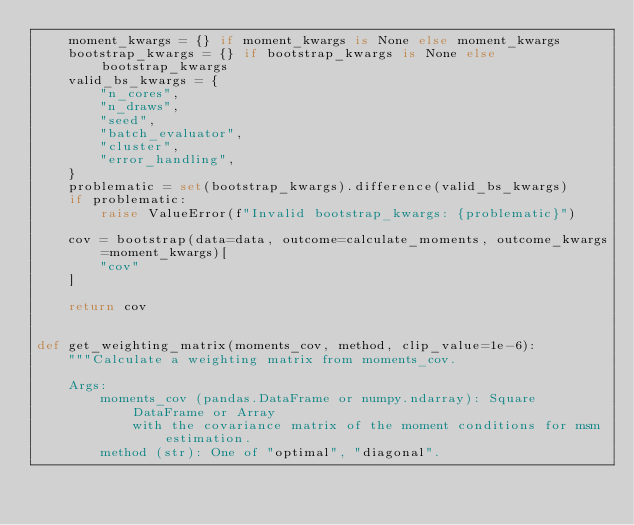Convert code to text. <code><loc_0><loc_0><loc_500><loc_500><_Python_>    moment_kwargs = {} if moment_kwargs is None else moment_kwargs
    bootstrap_kwargs = {} if bootstrap_kwargs is None else bootstrap_kwargs
    valid_bs_kwargs = {
        "n_cores",
        "n_draws",
        "seed",
        "batch_evaluator",
        "cluster",
        "error_handling",
    }
    problematic = set(bootstrap_kwargs).difference(valid_bs_kwargs)
    if problematic:
        raise ValueError(f"Invalid bootstrap_kwargs: {problematic}")

    cov = bootstrap(data=data, outcome=calculate_moments, outcome_kwargs=moment_kwargs)[
        "cov"
    ]

    return cov


def get_weighting_matrix(moments_cov, method, clip_value=1e-6):
    """Calculate a weighting matrix from moments_cov.

    Args:
        moments_cov (pandas.DataFrame or numpy.ndarray): Square DataFrame or Array
            with the covariance matrix of the moment conditions for msm estimation.
        method (str): One of "optimal", "diagonal".</code> 